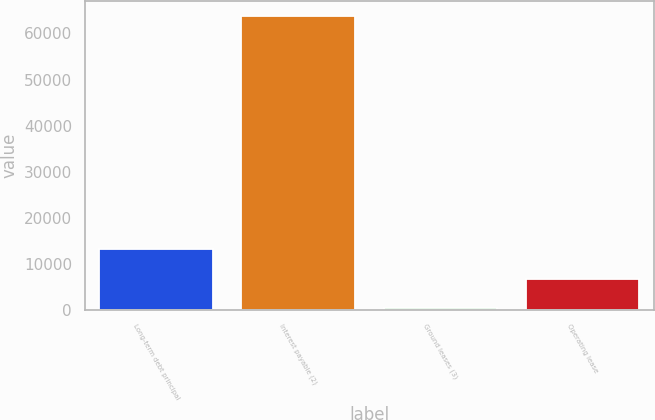Convert chart. <chart><loc_0><loc_0><loc_500><loc_500><bar_chart><fcel>Long-term debt principal<fcel>Interest payable (2)<fcel>Ground leases (3)<fcel>Operating lease<nl><fcel>13094.8<fcel>63862<fcel>403<fcel>6748.9<nl></chart> 